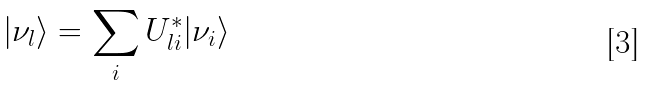<formula> <loc_0><loc_0><loc_500><loc_500>| \nu _ { l } \rangle = \sum _ { i } U ^ { * } _ { l i } | \nu _ { i } \rangle</formula> 